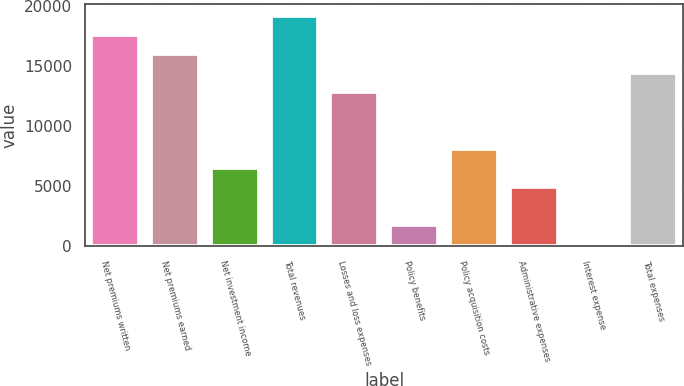Convert chart. <chart><loc_0><loc_0><loc_500><loc_500><bar_chart><fcel>Net premiums written<fcel>Net premiums earned<fcel>Net investment income<fcel>Total revenues<fcel>Losses and loss expenses<fcel>Policy benefits<fcel>Policy acquisition costs<fcel>Administrative expenses<fcel>Interest expense<fcel>Total expenses<nl><fcel>17584.2<fcel>16006<fcel>6536.8<fcel>19162.4<fcel>12849.6<fcel>1802.2<fcel>8115<fcel>4958.6<fcel>224<fcel>14427.8<nl></chart> 